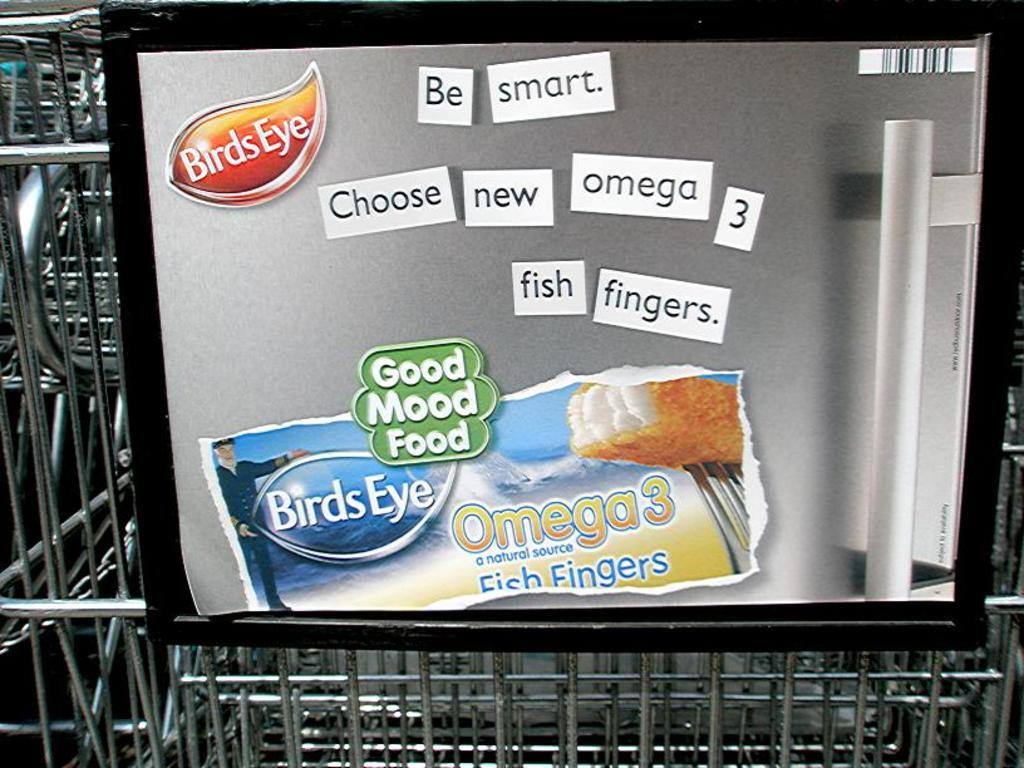Provide a one-sentence caption for the provided image. An advertisement for BIrds Eye Omega 3 Fish Fingers. 